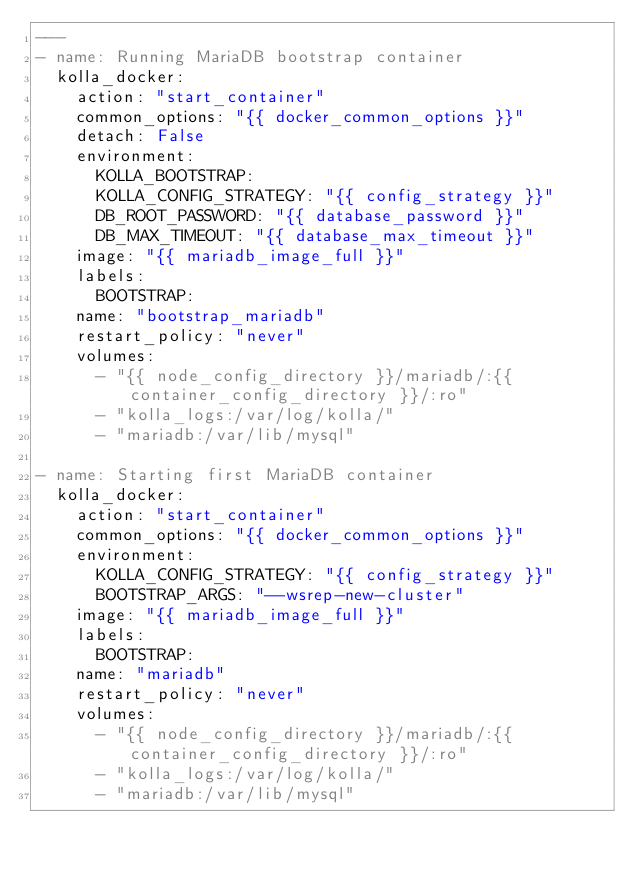Convert code to text. <code><loc_0><loc_0><loc_500><loc_500><_YAML_>---
- name: Running MariaDB bootstrap container
  kolla_docker:
    action: "start_container"
    common_options: "{{ docker_common_options }}"
    detach: False
    environment:
      KOLLA_BOOTSTRAP:
      KOLLA_CONFIG_STRATEGY: "{{ config_strategy }}"
      DB_ROOT_PASSWORD: "{{ database_password }}"
      DB_MAX_TIMEOUT: "{{ database_max_timeout }}"
    image: "{{ mariadb_image_full }}"
    labels:
      BOOTSTRAP:
    name: "bootstrap_mariadb"
    restart_policy: "never"
    volumes:
      - "{{ node_config_directory }}/mariadb/:{{ container_config_directory }}/:ro"
      - "kolla_logs:/var/log/kolla/"
      - "mariadb:/var/lib/mysql"

- name: Starting first MariaDB container
  kolla_docker:
    action: "start_container"
    common_options: "{{ docker_common_options }}"
    environment:
      KOLLA_CONFIG_STRATEGY: "{{ config_strategy }}"
      BOOTSTRAP_ARGS: "--wsrep-new-cluster"
    image: "{{ mariadb_image_full }}"
    labels:
      BOOTSTRAP:
    name: "mariadb"
    restart_policy: "never"
    volumes:
      - "{{ node_config_directory }}/mariadb/:{{ container_config_directory }}/:ro"
      - "kolla_logs:/var/log/kolla/"
      - "mariadb:/var/lib/mysql"
</code> 